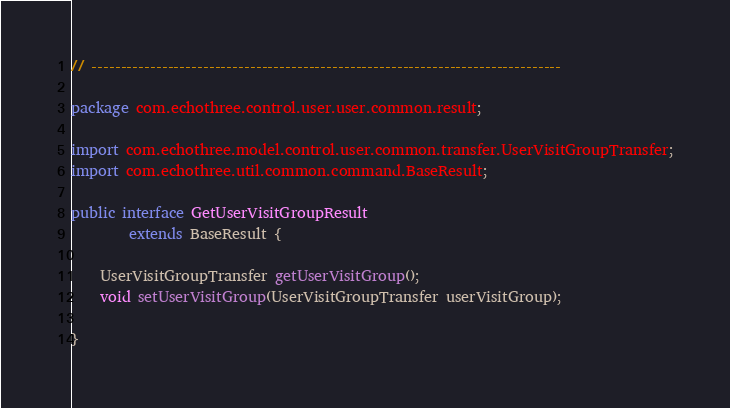<code> <loc_0><loc_0><loc_500><loc_500><_Java_>// --------------------------------------------------------------------------------

package com.echothree.control.user.user.common.result;

import com.echothree.model.control.user.common.transfer.UserVisitGroupTransfer;
import com.echothree.util.common.command.BaseResult;

public interface GetUserVisitGroupResult
        extends BaseResult {
    
    UserVisitGroupTransfer getUserVisitGroup();
    void setUserVisitGroup(UserVisitGroupTransfer userVisitGroup);
    
}
</code> 